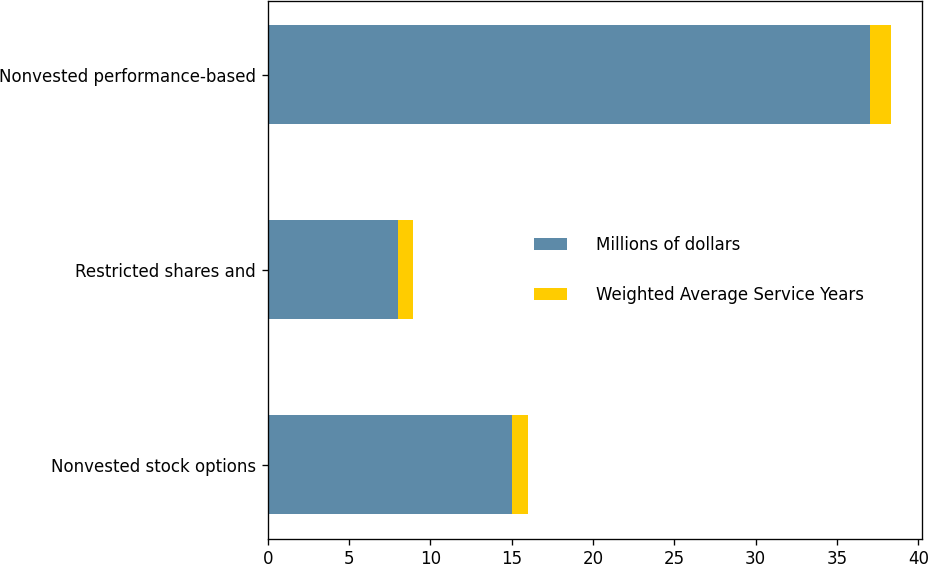Convert chart to OTSL. <chart><loc_0><loc_0><loc_500><loc_500><stacked_bar_chart><ecel><fcel>Nonvested stock options<fcel>Restricted shares and<fcel>Nonvested performance-based<nl><fcel>Millions of dollars<fcel>15<fcel>8<fcel>37<nl><fcel>Weighted Average Service Years<fcel>1<fcel>0.9<fcel>1.3<nl></chart> 